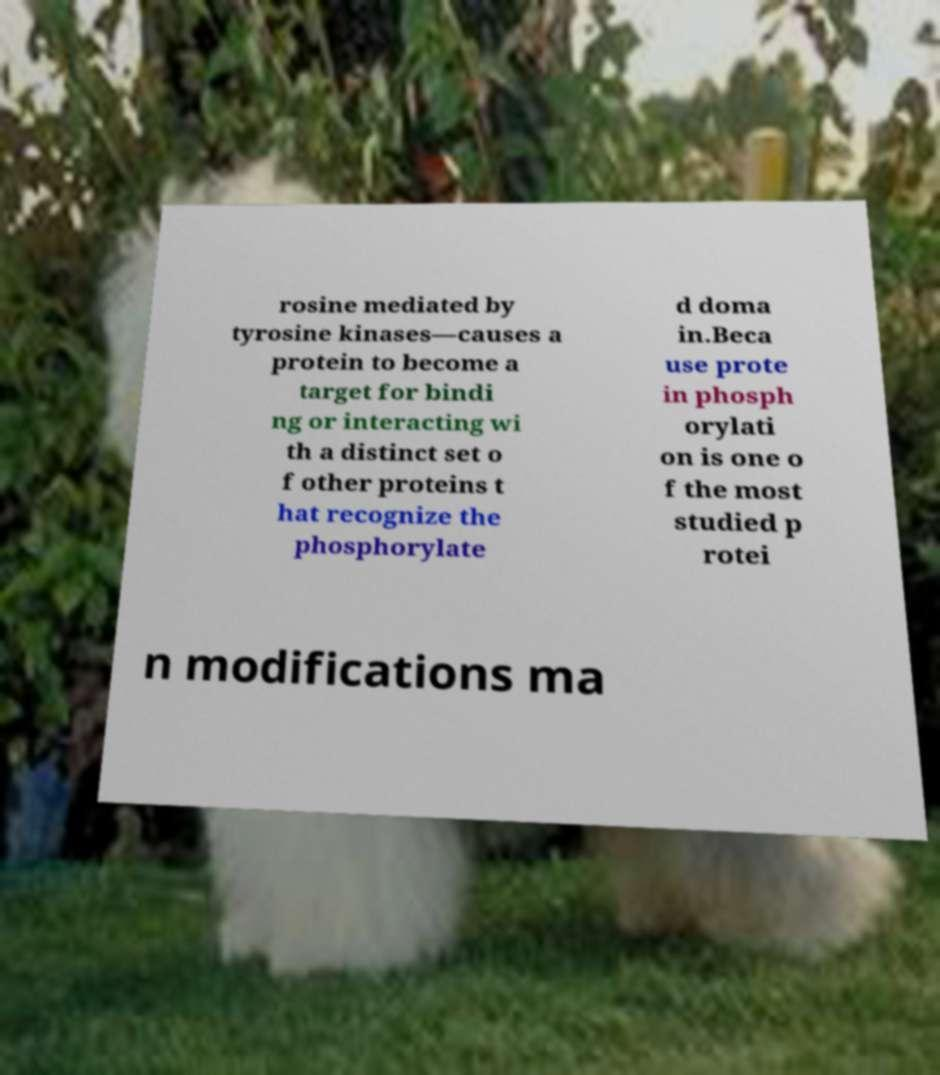I need the written content from this picture converted into text. Can you do that? rosine mediated by tyrosine kinases—causes a protein to become a target for bindi ng or interacting wi th a distinct set o f other proteins t hat recognize the phosphorylate d doma in.Beca use prote in phosph orylati on is one o f the most studied p rotei n modifications ma 